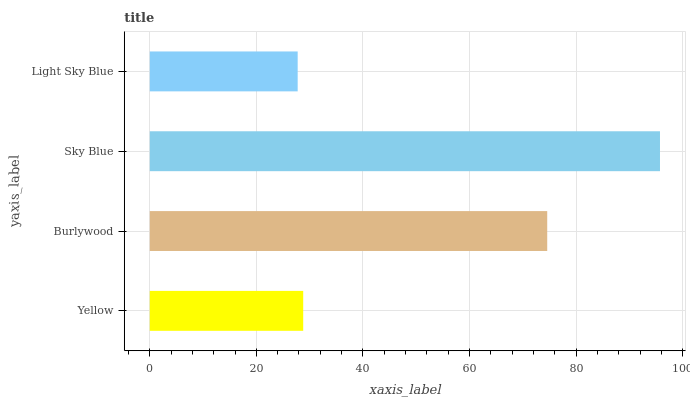Is Light Sky Blue the minimum?
Answer yes or no. Yes. Is Sky Blue the maximum?
Answer yes or no. Yes. Is Burlywood the minimum?
Answer yes or no. No. Is Burlywood the maximum?
Answer yes or no. No. Is Burlywood greater than Yellow?
Answer yes or no. Yes. Is Yellow less than Burlywood?
Answer yes or no. Yes. Is Yellow greater than Burlywood?
Answer yes or no. No. Is Burlywood less than Yellow?
Answer yes or no. No. Is Burlywood the high median?
Answer yes or no. Yes. Is Yellow the low median?
Answer yes or no. Yes. Is Light Sky Blue the high median?
Answer yes or no. No. Is Sky Blue the low median?
Answer yes or no. No. 